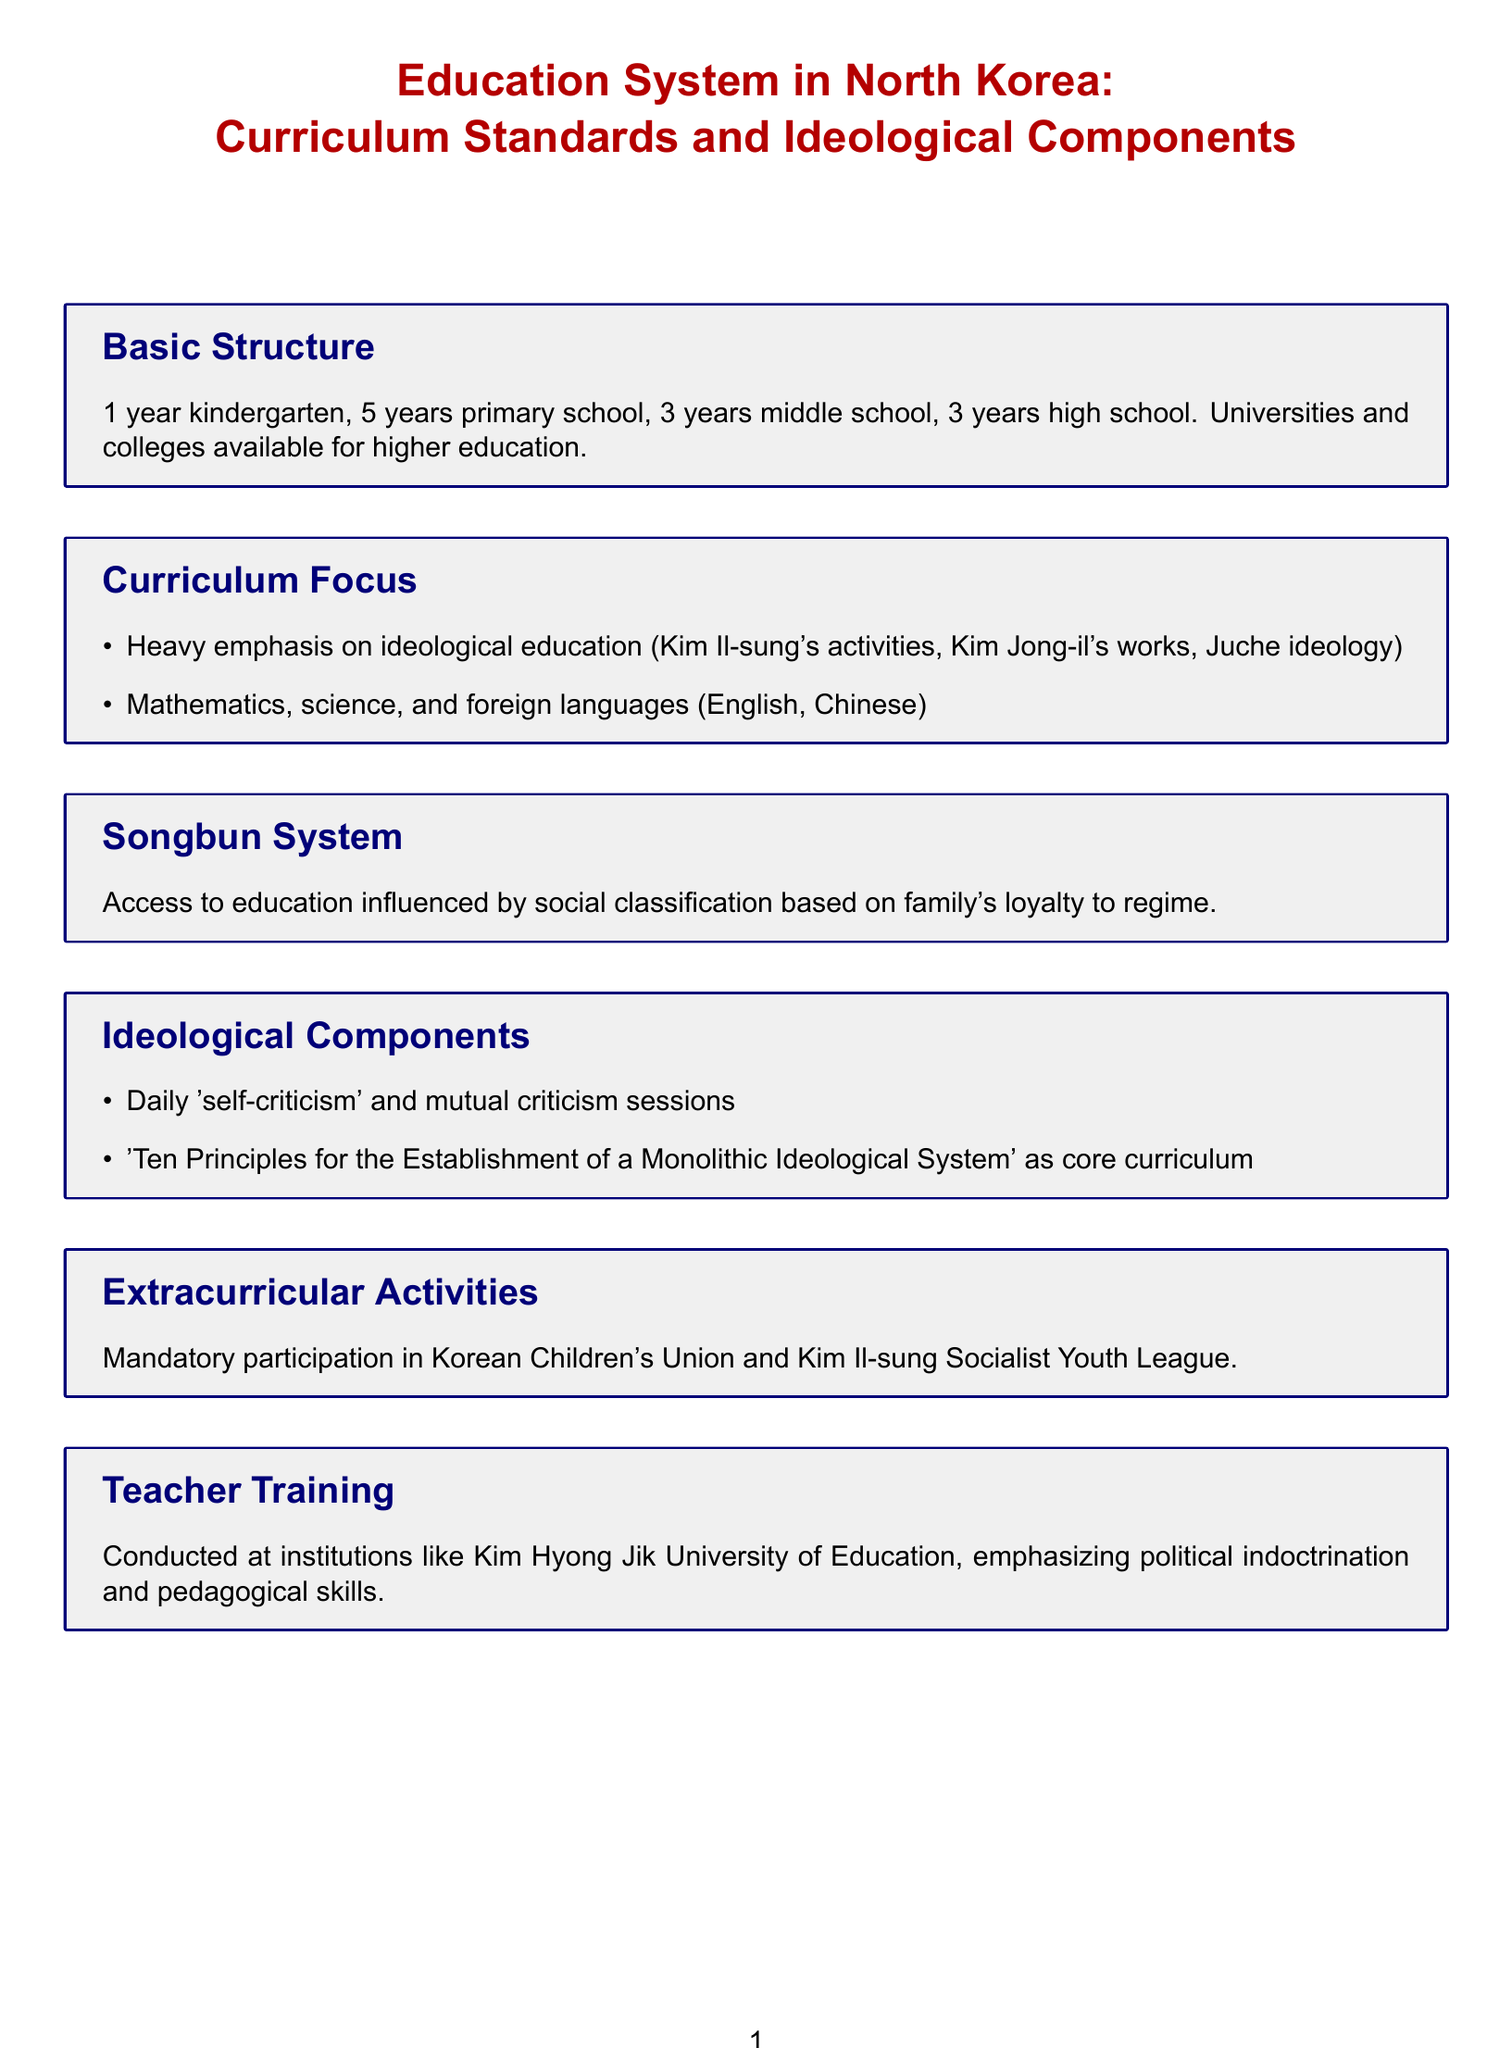What is the total duration of primary school? The total duration of primary school is given as 5 years in the document.
Answer: 5 years How many years is a typical high school education? High school education typically lasts for 3 years as stated in the document.
Answer: 3 years What ideology heavily influences the curriculum in North Korea? The document states that Juche ideology is a significant component of the curriculum.
Answer: Juche ideology What is the core curriculum focused on establishing a monolithic ideological system? The core curriculum focused on the 'Ten Principles for the Establishment of a Monolithic Ideological System' as mentioned in the document.
Answer: Ten Principles for the Establishment of a Monolithic Ideological System What organization must students participate in as part of their extracurricular activities? Students are required to be part of the Korean Children's Union as noted in the document.
Answer: Korean Children's Union Which university is mentioned for teacher training? The document refers to Kim Hyong Jik University of Education for teacher training purposes.
Answer: Kim Hyong Jik University of Education What aspect of education is influenced by the Songbun system? Access to education is influenced by the social classification based on family loyalty to the regime as outlined in the document.
Answer: Family loyalty What is a common practice in classrooms related to ideological training? The document states that daily 'self-criticism' and mutual criticism sessions are common.
Answer: Self-criticism sessions What subjects are included in the curriculum besides ideological education? The curriculum includes mathematics, science, and foreign languages, as mentioned in the document.
Answer: Mathematics, science, foreign languages 